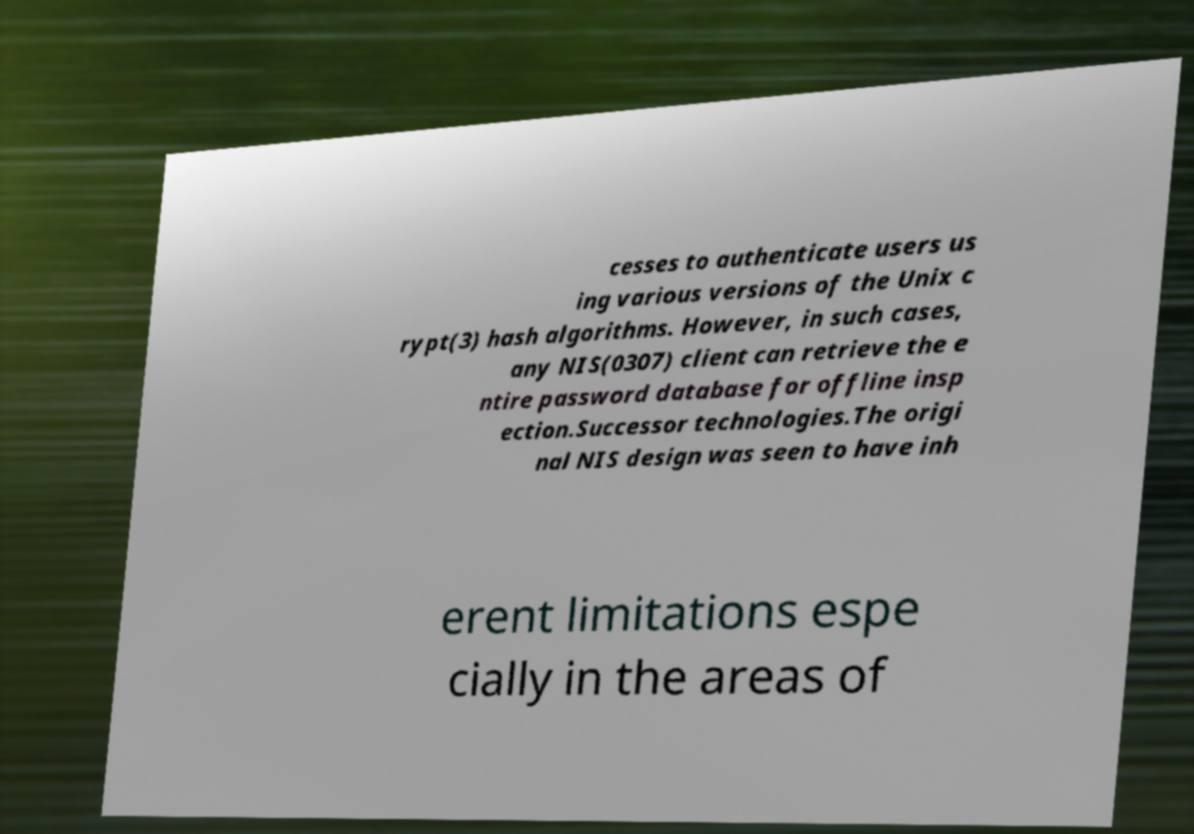Can you accurately transcribe the text from the provided image for me? cesses to authenticate users us ing various versions of the Unix c rypt(3) hash algorithms. However, in such cases, any NIS(0307) client can retrieve the e ntire password database for offline insp ection.Successor technologies.The origi nal NIS design was seen to have inh erent limitations espe cially in the areas of 